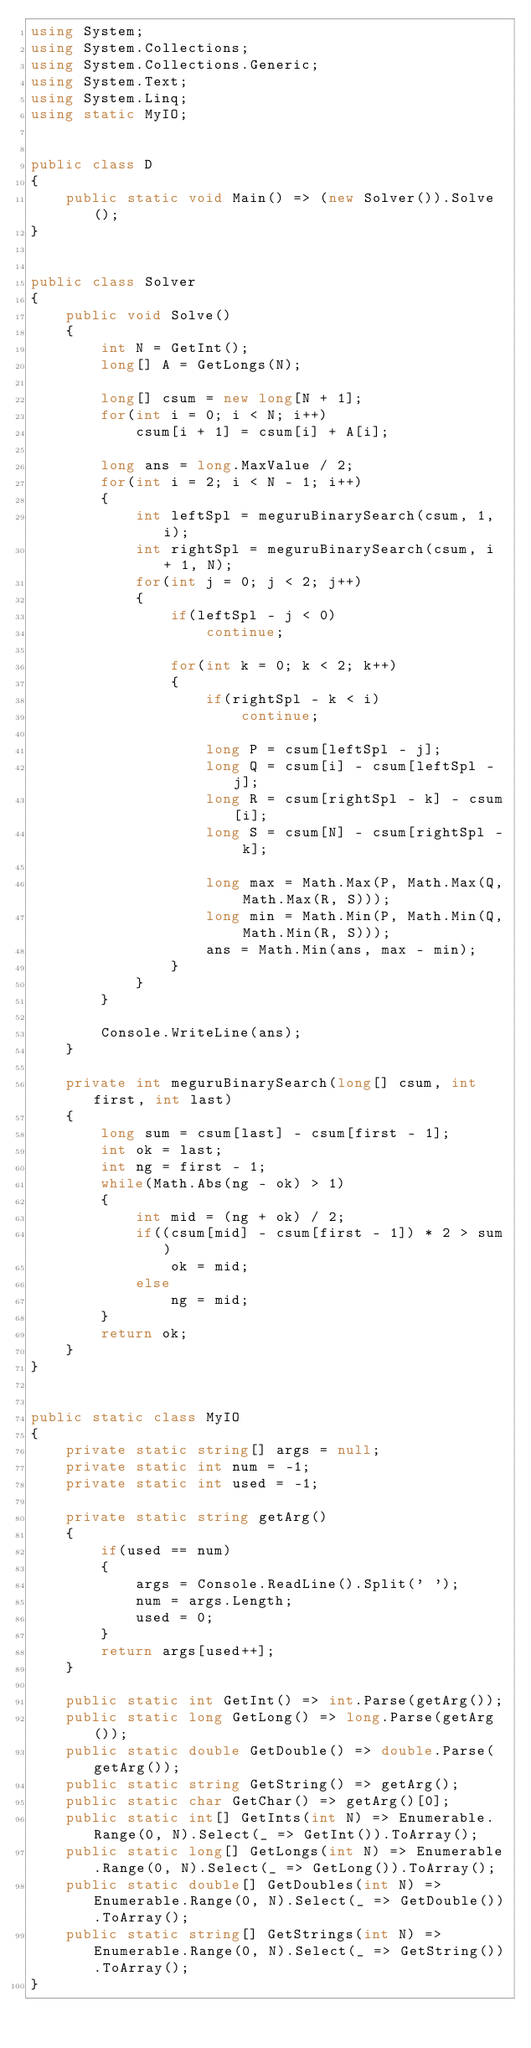Convert code to text. <code><loc_0><loc_0><loc_500><loc_500><_C#_>using System;
using System.Collections;
using System.Collections.Generic;
using System.Text;
using System.Linq;
using static MyIO;


public class D
{
	public static void Main() => (new Solver()).Solve();
}


public class Solver
{
	public void Solve()
	{
		int N = GetInt();
		long[] A = GetLongs(N);

		long[] csum = new long[N + 1];
		for(int i = 0; i < N; i++)
			csum[i + 1] = csum[i] + A[i];

		long ans = long.MaxValue / 2;
		for(int i = 2; i < N - 1; i++)
		{
			int leftSpl = meguruBinarySearch(csum, 1, i);
			int rightSpl = meguruBinarySearch(csum, i + 1, N);
			for(int j = 0; j < 2; j++)
			{
				if(leftSpl - j < 0)
					continue;

				for(int k = 0; k < 2; k++)
				{
					if(rightSpl - k < i)
						continue;
					
					long P = csum[leftSpl - j];
					long Q = csum[i] - csum[leftSpl - j];			
					long R = csum[rightSpl - k] - csum[i];
					long S = csum[N] - csum[rightSpl - k];
					
					long max = Math.Max(P, Math.Max(Q, Math.Max(R, S)));
					long min = Math.Min(P, Math.Min(Q, Math.Min(R, S)));
					ans = Math.Min(ans, max - min);
				}				
			}
		}

		Console.WriteLine(ans);
	}

	private int meguruBinarySearch(long[] csum, int first, int last)
	{
		long sum = csum[last] - csum[first - 1];
		int ok = last;
		int ng = first - 1;
		while(Math.Abs(ng - ok) > 1)
		{
			int mid = (ng + ok) / 2;
			if((csum[mid] - csum[first - 1]) * 2 > sum)
				ok = mid;
			else
				ng = mid;
		}
		return ok;
	}
}


public static class MyIO
{
	private static string[] args = null;
	private static int num = -1;
	private static int used = -1;

	private static string getArg()
	{
		if(used == num)
		{
			args = Console.ReadLine().Split(' ');
			num = args.Length;
			used = 0;
		}
		return args[used++];
	}

	public static int GetInt() => int.Parse(getArg());
	public static long GetLong() => long.Parse(getArg());
	public static double GetDouble() => double.Parse(getArg());
	public static string GetString() => getArg();
	public static char GetChar() => getArg()[0];
	public static int[] GetInts(int N) => Enumerable.Range(0, N).Select(_ => GetInt()).ToArray();
	public static long[] GetLongs(int N) => Enumerable.Range(0, N).Select(_ => GetLong()).ToArray();
	public static double[] GetDoubles(int N) => Enumerable.Range(0, N).Select(_ => GetDouble()).ToArray();
	public static string[] GetStrings(int N) => Enumerable.Range(0, N).Select(_ => GetString()).ToArray();
}
</code> 